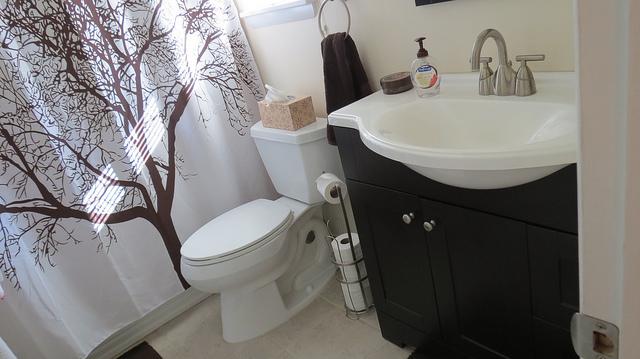What is this?
Answer briefly. Bathroom. Is the toilet seat up?
Short answer required. No. What birds are shown on the shower curtain?
Be succinct. 0. Where could the flush lever be?
Quick response, please. Left. Where is the box of tissues?
Keep it brief. On toilet. 